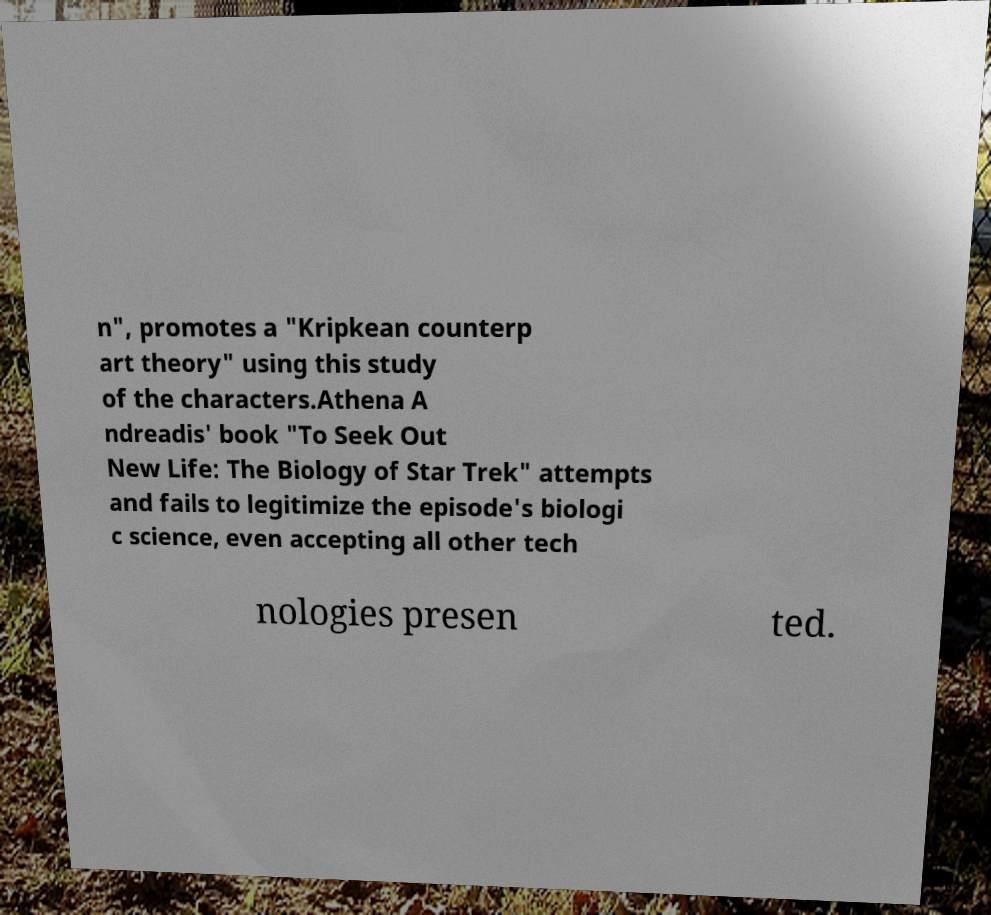There's text embedded in this image that I need extracted. Can you transcribe it verbatim? n", promotes a "Kripkean counterp art theory" using this study of the characters.Athena A ndreadis' book "To Seek Out New Life: The Biology of Star Trek" attempts and fails to legitimize the episode's biologi c science, even accepting all other tech nologies presen ted. 